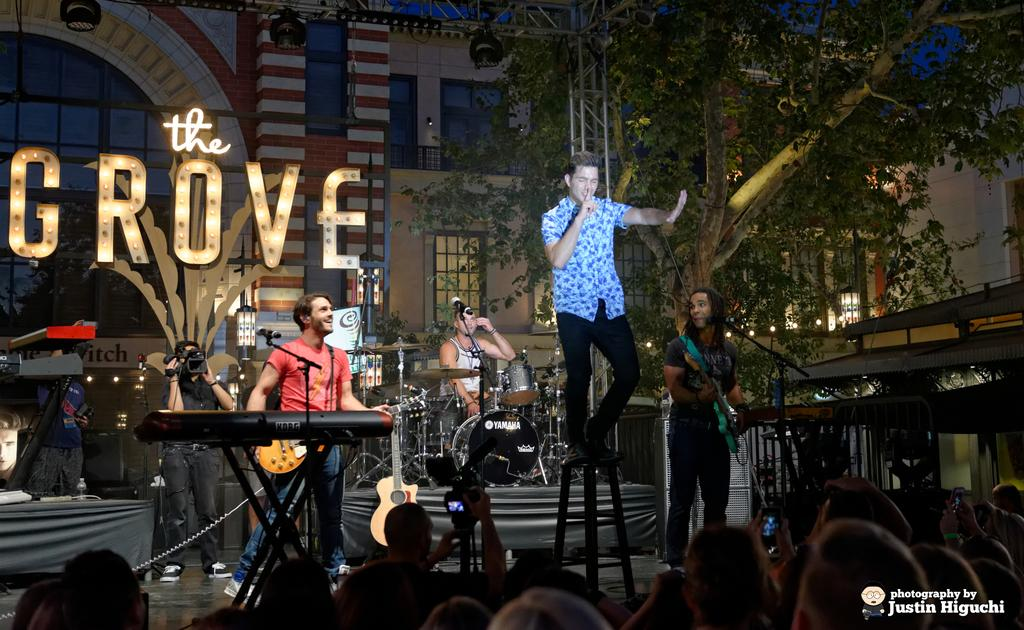What can be seen in the image involving people? There are people in the image. What objects are related to music in the image? There are musical instruments and microphones in the image. What equipment is used for recording or capturing the event in the image? There are cameras in the image. What is providing illumination in the image? There are lights in the image. What type of structures are visible in the image? There are buildings in the image. What type of natural element is present in the image? There is a tree in the image. What type of signage or display can be seen in the image? There are boards in the image. What architectural feature is present in the buildings? There are windows in the image. What type of bread is being used as a rhythm instrument in the image? There is no bread or rhythm instrument present in the image. What title is given to the loaf of bread in the image? There is no loaf of bread present in the image, so it cannot have a title. 